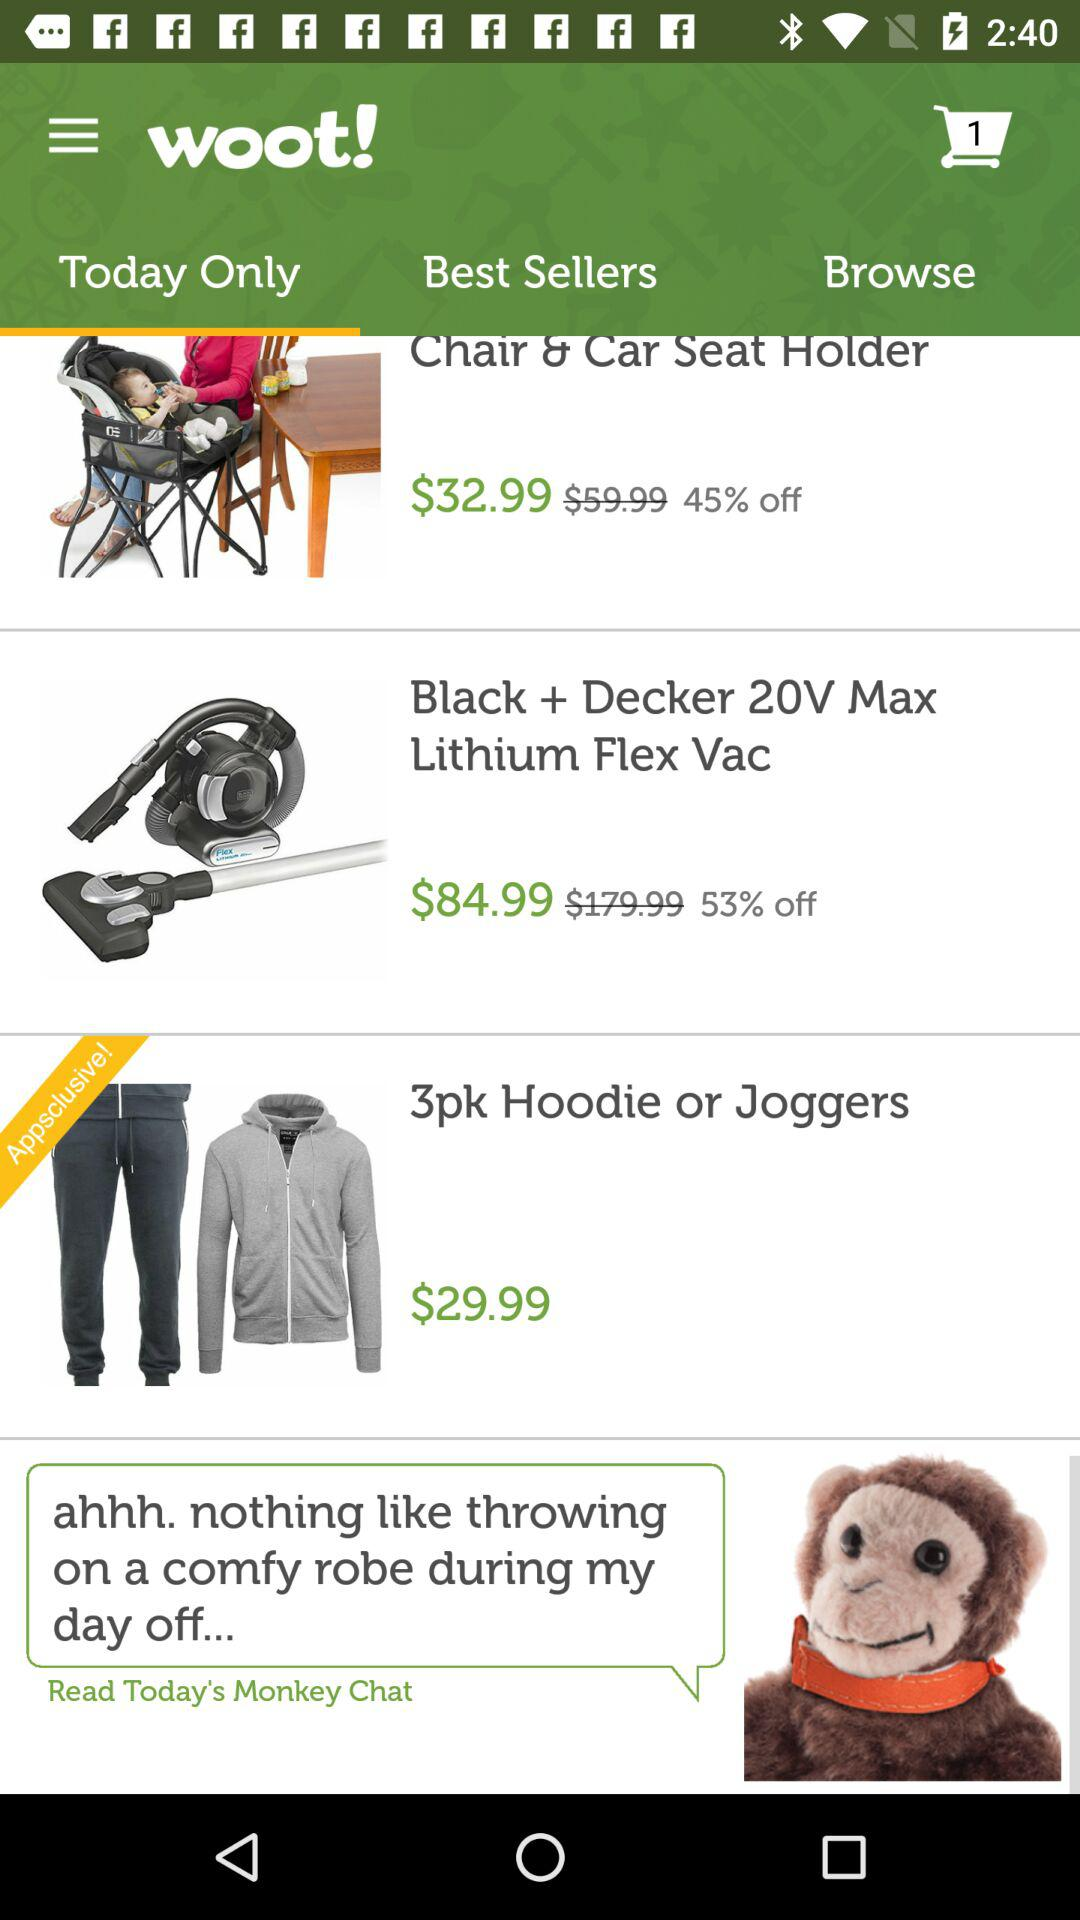What is the price of "3pk Hoodie or Joggers"? The price of a "3pk Hoodie or Joggers" is $29.99. 